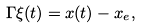Convert formula to latex. <formula><loc_0><loc_0><loc_500><loc_500>\Gamma \xi ( t ) = x ( t ) - x _ { e } ,</formula> 